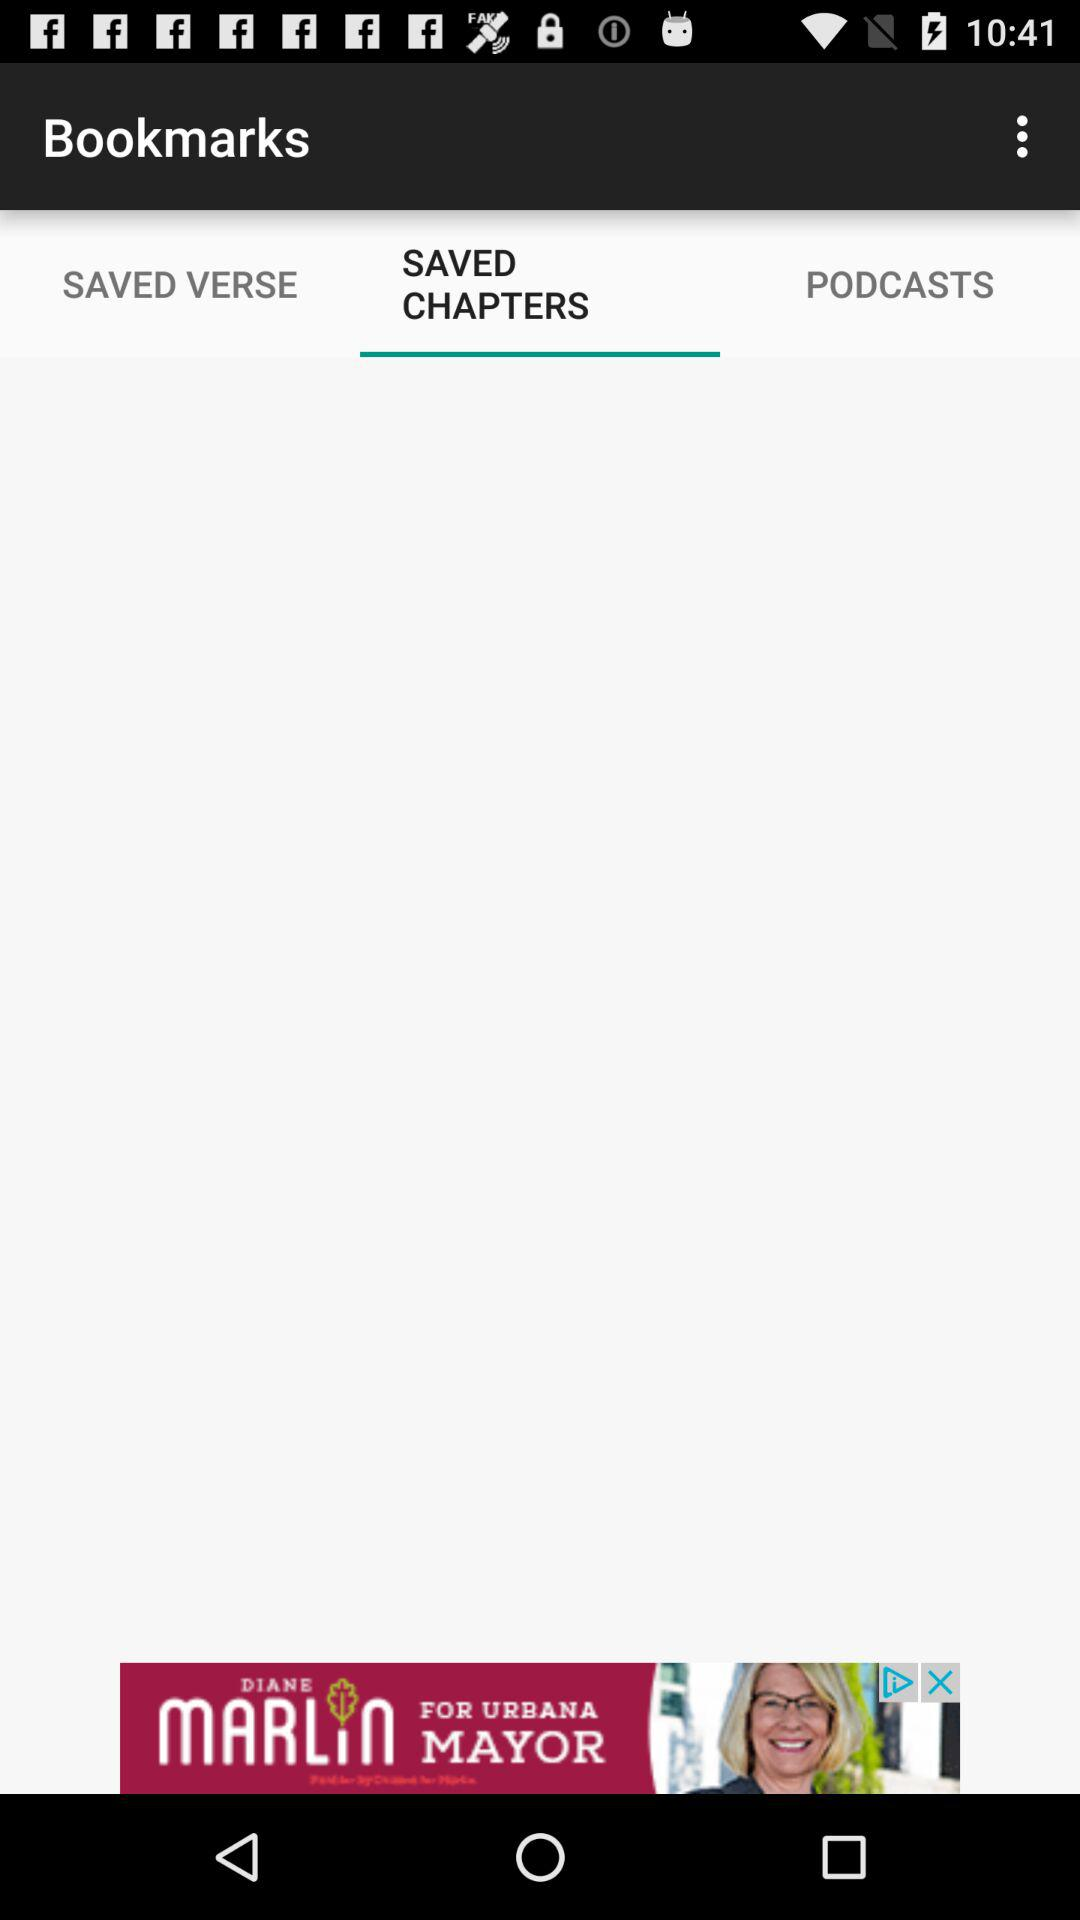Which verses have been saved?
When the provided information is insufficient, respond with <no answer>. <no answer> 